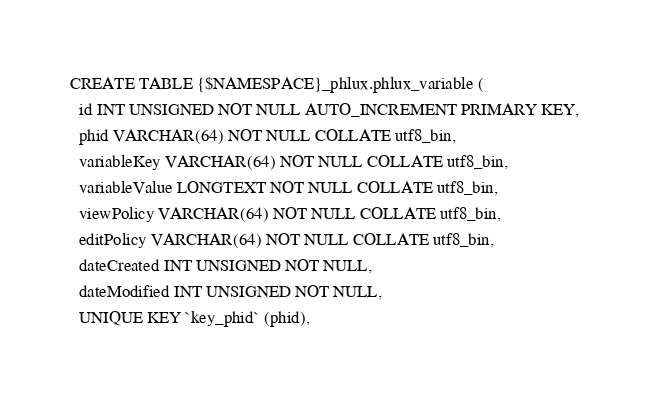Convert code to text. <code><loc_0><loc_0><loc_500><loc_500><_SQL_>CREATE TABLE {$NAMESPACE}_phlux.phlux_variable (
  id INT UNSIGNED NOT NULL AUTO_INCREMENT PRIMARY KEY,
  phid VARCHAR(64) NOT NULL COLLATE utf8_bin,
  variableKey VARCHAR(64) NOT NULL COLLATE utf8_bin,
  variableValue LONGTEXT NOT NULL COLLATE utf8_bin,
  viewPolicy VARCHAR(64) NOT NULL COLLATE utf8_bin,
  editPolicy VARCHAR(64) NOT NULL COLLATE utf8_bin,
  dateCreated INT UNSIGNED NOT NULL,
  dateModified INT UNSIGNED NOT NULL,
  UNIQUE KEY `key_phid` (phid),</code> 